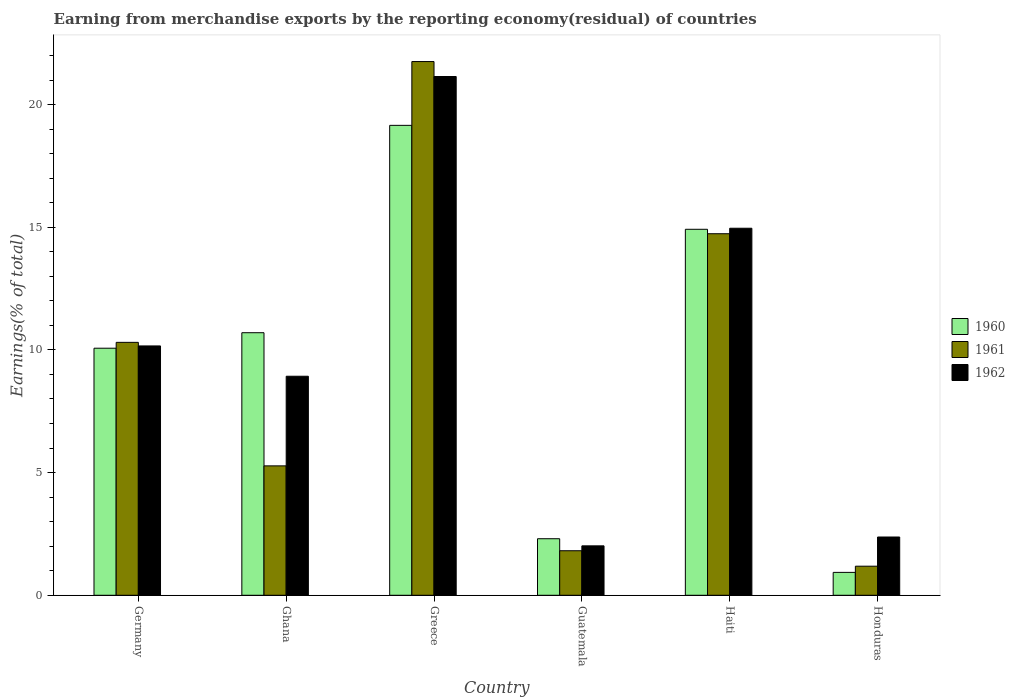How many different coloured bars are there?
Your answer should be compact. 3. Are the number of bars per tick equal to the number of legend labels?
Make the answer very short. Yes. Are the number of bars on each tick of the X-axis equal?
Offer a terse response. Yes. How many bars are there on the 4th tick from the left?
Give a very brief answer. 3. What is the label of the 6th group of bars from the left?
Give a very brief answer. Honduras. In how many cases, is the number of bars for a given country not equal to the number of legend labels?
Your answer should be compact. 0. What is the percentage of amount earned from merchandise exports in 1961 in Guatemala?
Your answer should be very brief. 1.81. Across all countries, what is the maximum percentage of amount earned from merchandise exports in 1960?
Give a very brief answer. 19.15. Across all countries, what is the minimum percentage of amount earned from merchandise exports in 1960?
Offer a very short reply. 0.93. In which country was the percentage of amount earned from merchandise exports in 1960 minimum?
Keep it short and to the point. Honduras. What is the total percentage of amount earned from merchandise exports in 1962 in the graph?
Your response must be concise. 59.58. What is the difference between the percentage of amount earned from merchandise exports in 1961 in Ghana and that in Guatemala?
Your answer should be very brief. 3.46. What is the difference between the percentage of amount earned from merchandise exports in 1960 in Ghana and the percentage of amount earned from merchandise exports in 1962 in Haiti?
Give a very brief answer. -4.26. What is the average percentage of amount earned from merchandise exports in 1960 per country?
Ensure brevity in your answer.  9.68. What is the difference between the percentage of amount earned from merchandise exports of/in 1961 and percentage of amount earned from merchandise exports of/in 1960 in Germany?
Your response must be concise. 0.24. What is the ratio of the percentage of amount earned from merchandise exports in 1960 in Germany to that in Greece?
Ensure brevity in your answer.  0.53. Is the difference between the percentage of amount earned from merchandise exports in 1961 in Ghana and Greece greater than the difference between the percentage of amount earned from merchandise exports in 1960 in Ghana and Greece?
Your answer should be compact. No. What is the difference between the highest and the second highest percentage of amount earned from merchandise exports in 1962?
Offer a very short reply. -10.98. What is the difference between the highest and the lowest percentage of amount earned from merchandise exports in 1960?
Offer a very short reply. 18.22. In how many countries, is the percentage of amount earned from merchandise exports in 1962 greater than the average percentage of amount earned from merchandise exports in 1962 taken over all countries?
Offer a terse response. 3. What does the 2nd bar from the left in Greece represents?
Keep it short and to the point. 1961. What does the 2nd bar from the right in Guatemala represents?
Provide a short and direct response. 1961. Is it the case that in every country, the sum of the percentage of amount earned from merchandise exports in 1962 and percentage of amount earned from merchandise exports in 1960 is greater than the percentage of amount earned from merchandise exports in 1961?
Offer a very short reply. Yes. How many bars are there?
Your answer should be compact. 18. Are all the bars in the graph horizontal?
Make the answer very short. No. Does the graph contain grids?
Provide a succinct answer. No. Where does the legend appear in the graph?
Your answer should be compact. Center right. How many legend labels are there?
Ensure brevity in your answer.  3. How are the legend labels stacked?
Your answer should be very brief. Vertical. What is the title of the graph?
Provide a short and direct response. Earning from merchandise exports by the reporting economy(residual) of countries. What is the label or title of the X-axis?
Your answer should be compact. Country. What is the label or title of the Y-axis?
Make the answer very short. Earnings(% of total). What is the Earnings(% of total) of 1960 in Germany?
Ensure brevity in your answer.  10.07. What is the Earnings(% of total) of 1961 in Germany?
Your response must be concise. 10.31. What is the Earnings(% of total) of 1962 in Germany?
Your answer should be very brief. 10.16. What is the Earnings(% of total) in 1960 in Ghana?
Your answer should be very brief. 10.7. What is the Earnings(% of total) of 1961 in Ghana?
Your response must be concise. 5.27. What is the Earnings(% of total) in 1962 in Ghana?
Offer a very short reply. 8.93. What is the Earnings(% of total) of 1960 in Greece?
Provide a short and direct response. 19.15. What is the Earnings(% of total) in 1961 in Greece?
Keep it short and to the point. 21.75. What is the Earnings(% of total) in 1962 in Greece?
Offer a very short reply. 21.14. What is the Earnings(% of total) in 1960 in Guatemala?
Your response must be concise. 2.3. What is the Earnings(% of total) of 1961 in Guatemala?
Your response must be concise. 1.81. What is the Earnings(% of total) in 1962 in Guatemala?
Keep it short and to the point. 2.01. What is the Earnings(% of total) of 1960 in Haiti?
Give a very brief answer. 14.92. What is the Earnings(% of total) in 1961 in Haiti?
Provide a succinct answer. 14.74. What is the Earnings(% of total) in 1962 in Haiti?
Provide a short and direct response. 14.96. What is the Earnings(% of total) in 1960 in Honduras?
Keep it short and to the point. 0.93. What is the Earnings(% of total) of 1961 in Honduras?
Provide a short and direct response. 1.19. What is the Earnings(% of total) of 1962 in Honduras?
Offer a terse response. 2.38. Across all countries, what is the maximum Earnings(% of total) in 1960?
Make the answer very short. 19.15. Across all countries, what is the maximum Earnings(% of total) in 1961?
Your answer should be compact. 21.75. Across all countries, what is the maximum Earnings(% of total) in 1962?
Give a very brief answer. 21.14. Across all countries, what is the minimum Earnings(% of total) in 1960?
Offer a very short reply. 0.93. Across all countries, what is the minimum Earnings(% of total) in 1961?
Your answer should be compact. 1.19. Across all countries, what is the minimum Earnings(% of total) in 1962?
Provide a succinct answer. 2.01. What is the total Earnings(% of total) in 1960 in the graph?
Ensure brevity in your answer.  58.08. What is the total Earnings(% of total) of 1961 in the graph?
Your answer should be compact. 55.07. What is the total Earnings(% of total) of 1962 in the graph?
Offer a terse response. 59.58. What is the difference between the Earnings(% of total) of 1960 in Germany and that in Ghana?
Offer a very short reply. -0.63. What is the difference between the Earnings(% of total) in 1961 in Germany and that in Ghana?
Provide a succinct answer. 5.03. What is the difference between the Earnings(% of total) of 1962 in Germany and that in Ghana?
Offer a terse response. 1.24. What is the difference between the Earnings(% of total) in 1960 in Germany and that in Greece?
Your answer should be very brief. -9.08. What is the difference between the Earnings(% of total) of 1961 in Germany and that in Greece?
Provide a short and direct response. -11.44. What is the difference between the Earnings(% of total) in 1962 in Germany and that in Greece?
Your answer should be compact. -10.98. What is the difference between the Earnings(% of total) in 1960 in Germany and that in Guatemala?
Provide a short and direct response. 7.76. What is the difference between the Earnings(% of total) of 1961 in Germany and that in Guatemala?
Offer a very short reply. 8.49. What is the difference between the Earnings(% of total) of 1962 in Germany and that in Guatemala?
Keep it short and to the point. 8.15. What is the difference between the Earnings(% of total) in 1960 in Germany and that in Haiti?
Give a very brief answer. -4.85. What is the difference between the Earnings(% of total) of 1961 in Germany and that in Haiti?
Provide a short and direct response. -4.43. What is the difference between the Earnings(% of total) of 1962 in Germany and that in Haiti?
Make the answer very short. -4.8. What is the difference between the Earnings(% of total) in 1960 in Germany and that in Honduras?
Your answer should be very brief. 9.14. What is the difference between the Earnings(% of total) in 1961 in Germany and that in Honduras?
Make the answer very short. 9.12. What is the difference between the Earnings(% of total) of 1962 in Germany and that in Honduras?
Provide a succinct answer. 7.79. What is the difference between the Earnings(% of total) of 1960 in Ghana and that in Greece?
Your answer should be compact. -8.45. What is the difference between the Earnings(% of total) of 1961 in Ghana and that in Greece?
Offer a very short reply. -16.48. What is the difference between the Earnings(% of total) of 1962 in Ghana and that in Greece?
Offer a very short reply. -12.22. What is the difference between the Earnings(% of total) of 1960 in Ghana and that in Guatemala?
Ensure brevity in your answer.  8.4. What is the difference between the Earnings(% of total) of 1961 in Ghana and that in Guatemala?
Keep it short and to the point. 3.46. What is the difference between the Earnings(% of total) of 1962 in Ghana and that in Guatemala?
Provide a succinct answer. 6.91. What is the difference between the Earnings(% of total) of 1960 in Ghana and that in Haiti?
Give a very brief answer. -4.22. What is the difference between the Earnings(% of total) in 1961 in Ghana and that in Haiti?
Provide a succinct answer. -9.46. What is the difference between the Earnings(% of total) in 1962 in Ghana and that in Haiti?
Your response must be concise. -6.03. What is the difference between the Earnings(% of total) in 1960 in Ghana and that in Honduras?
Keep it short and to the point. 9.77. What is the difference between the Earnings(% of total) of 1961 in Ghana and that in Honduras?
Your response must be concise. 4.09. What is the difference between the Earnings(% of total) in 1962 in Ghana and that in Honduras?
Keep it short and to the point. 6.55. What is the difference between the Earnings(% of total) of 1960 in Greece and that in Guatemala?
Ensure brevity in your answer.  16.85. What is the difference between the Earnings(% of total) of 1961 in Greece and that in Guatemala?
Keep it short and to the point. 19.94. What is the difference between the Earnings(% of total) in 1962 in Greece and that in Guatemala?
Ensure brevity in your answer.  19.13. What is the difference between the Earnings(% of total) in 1960 in Greece and that in Haiti?
Offer a terse response. 4.24. What is the difference between the Earnings(% of total) in 1961 in Greece and that in Haiti?
Give a very brief answer. 7.02. What is the difference between the Earnings(% of total) in 1962 in Greece and that in Haiti?
Make the answer very short. 6.18. What is the difference between the Earnings(% of total) in 1960 in Greece and that in Honduras?
Provide a succinct answer. 18.22. What is the difference between the Earnings(% of total) of 1961 in Greece and that in Honduras?
Provide a succinct answer. 20.57. What is the difference between the Earnings(% of total) of 1962 in Greece and that in Honduras?
Provide a succinct answer. 18.77. What is the difference between the Earnings(% of total) of 1960 in Guatemala and that in Haiti?
Provide a succinct answer. -12.61. What is the difference between the Earnings(% of total) in 1961 in Guatemala and that in Haiti?
Offer a very short reply. -12.92. What is the difference between the Earnings(% of total) of 1962 in Guatemala and that in Haiti?
Keep it short and to the point. -12.94. What is the difference between the Earnings(% of total) of 1960 in Guatemala and that in Honduras?
Provide a short and direct response. 1.37. What is the difference between the Earnings(% of total) in 1961 in Guatemala and that in Honduras?
Keep it short and to the point. 0.63. What is the difference between the Earnings(% of total) of 1962 in Guatemala and that in Honduras?
Provide a short and direct response. -0.36. What is the difference between the Earnings(% of total) of 1960 in Haiti and that in Honduras?
Ensure brevity in your answer.  13.98. What is the difference between the Earnings(% of total) in 1961 in Haiti and that in Honduras?
Provide a short and direct response. 13.55. What is the difference between the Earnings(% of total) in 1962 in Haiti and that in Honduras?
Your answer should be very brief. 12.58. What is the difference between the Earnings(% of total) of 1960 in Germany and the Earnings(% of total) of 1961 in Ghana?
Offer a terse response. 4.79. What is the difference between the Earnings(% of total) of 1960 in Germany and the Earnings(% of total) of 1962 in Ghana?
Provide a succinct answer. 1.14. What is the difference between the Earnings(% of total) in 1961 in Germany and the Earnings(% of total) in 1962 in Ghana?
Give a very brief answer. 1.38. What is the difference between the Earnings(% of total) in 1960 in Germany and the Earnings(% of total) in 1961 in Greece?
Ensure brevity in your answer.  -11.68. What is the difference between the Earnings(% of total) of 1960 in Germany and the Earnings(% of total) of 1962 in Greece?
Give a very brief answer. -11.07. What is the difference between the Earnings(% of total) of 1961 in Germany and the Earnings(% of total) of 1962 in Greece?
Keep it short and to the point. -10.84. What is the difference between the Earnings(% of total) of 1960 in Germany and the Earnings(% of total) of 1961 in Guatemala?
Your answer should be very brief. 8.25. What is the difference between the Earnings(% of total) of 1960 in Germany and the Earnings(% of total) of 1962 in Guatemala?
Make the answer very short. 8.05. What is the difference between the Earnings(% of total) of 1961 in Germany and the Earnings(% of total) of 1962 in Guatemala?
Provide a succinct answer. 8.29. What is the difference between the Earnings(% of total) of 1960 in Germany and the Earnings(% of total) of 1961 in Haiti?
Make the answer very short. -4.67. What is the difference between the Earnings(% of total) of 1960 in Germany and the Earnings(% of total) of 1962 in Haiti?
Keep it short and to the point. -4.89. What is the difference between the Earnings(% of total) of 1961 in Germany and the Earnings(% of total) of 1962 in Haiti?
Your answer should be very brief. -4.65. What is the difference between the Earnings(% of total) in 1960 in Germany and the Earnings(% of total) in 1961 in Honduras?
Give a very brief answer. 8.88. What is the difference between the Earnings(% of total) in 1960 in Germany and the Earnings(% of total) in 1962 in Honduras?
Offer a very short reply. 7.69. What is the difference between the Earnings(% of total) in 1961 in Germany and the Earnings(% of total) in 1962 in Honduras?
Keep it short and to the point. 7.93. What is the difference between the Earnings(% of total) of 1960 in Ghana and the Earnings(% of total) of 1961 in Greece?
Offer a very short reply. -11.05. What is the difference between the Earnings(% of total) of 1960 in Ghana and the Earnings(% of total) of 1962 in Greece?
Ensure brevity in your answer.  -10.44. What is the difference between the Earnings(% of total) in 1961 in Ghana and the Earnings(% of total) in 1962 in Greece?
Offer a terse response. -15.87. What is the difference between the Earnings(% of total) in 1960 in Ghana and the Earnings(% of total) in 1961 in Guatemala?
Your response must be concise. 8.89. What is the difference between the Earnings(% of total) of 1960 in Ghana and the Earnings(% of total) of 1962 in Guatemala?
Give a very brief answer. 8.69. What is the difference between the Earnings(% of total) in 1961 in Ghana and the Earnings(% of total) in 1962 in Guatemala?
Offer a very short reply. 3.26. What is the difference between the Earnings(% of total) of 1960 in Ghana and the Earnings(% of total) of 1961 in Haiti?
Provide a succinct answer. -4.03. What is the difference between the Earnings(% of total) of 1960 in Ghana and the Earnings(% of total) of 1962 in Haiti?
Provide a short and direct response. -4.26. What is the difference between the Earnings(% of total) in 1961 in Ghana and the Earnings(% of total) in 1962 in Haiti?
Provide a succinct answer. -9.68. What is the difference between the Earnings(% of total) in 1960 in Ghana and the Earnings(% of total) in 1961 in Honduras?
Keep it short and to the point. 9.52. What is the difference between the Earnings(% of total) of 1960 in Ghana and the Earnings(% of total) of 1962 in Honduras?
Give a very brief answer. 8.33. What is the difference between the Earnings(% of total) in 1961 in Ghana and the Earnings(% of total) in 1962 in Honduras?
Your response must be concise. 2.9. What is the difference between the Earnings(% of total) in 1960 in Greece and the Earnings(% of total) in 1961 in Guatemala?
Offer a terse response. 17.34. What is the difference between the Earnings(% of total) in 1960 in Greece and the Earnings(% of total) in 1962 in Guatemala?
Make the answer very short. 17.14. What is the difference between the Earnings(% of total) in 1961 in Greece and the Earnings(% of total) in 1962 in Guatemala?
Provide a short and direct response. 19.74. What is the difference between the Earnings(% of total) in 1960 in Greece and the Earnings(% of total) in 1961 in Haiti?
Offer a very short reply. 4.42. What is the difference between the Earnings(% of total) in 1960 in Greece and the Earnings(% of total) in 1962 in Haiti?
Offer a very short reply. 4.19. What is the difference between the Earnings(% of total) in 1961 in Greece and the Earnings(% of total) in 1962 in Haiti?
Your answer should be compact. 6.79. What is the difference between the Earnings(% of total) in 1960 in Greece and the Earnings(% of total) in 1961 in Honduras?
Make the answer very short. 17.97. What is the difference between the Earnings(% of total) in 1960 in Greece and the Earnings(% of total) in 1962 in Honduras?
Provide a short and direct response. 16.78. What is the difference between the Earnings(% of total) of 1961 in Greece and the Earnings(% of total) of 1962 in Honduras?
Your response must be concise. 19.38. What is the difference between the Earnings(% of total) in 1960 in Guatemala and the Earnings(% of total) in 1961 in Haiti?
Offer a terse response. -12.43. What is the difference between the Earnings(% of total) in 1960 in Guatemala and the Earnings(% of total) in 1962 in Haiti?
Offer a terse response. -12.65. What is the difference between the Earnings(% of total) of 1961 in Guatemala and the Earnings(% of total) of 1962 in Haiti?
Give a very brief answer. -13.14. What is the difference between the Earnings(% of total) in 1960 in Guatemala and the Earnings(% of total) in 1961 in Honduras?
Give a very brief answer. 1.12. What is the difference between the Earnings(% of total) of 1960 in Guatemala and the Earnings(% of total) of 1962 in Honduras?
Your answer should be compact. -0.07. What is the difference between the Earnings(% of total) in 1961 in Guatemala and the Earnings(% of total) in 1962 in Honduras?
Ensure brevity in your answer.  -0.56. What is the difference between the Earnings(% of total) of 1960 in Haiti and the Earnings(% of total) of 1961 in Honduras?
Provide a short and direct response. 13.73. What is the difference between the Earnings(% of total) of 1960 in Haiti and the Earnings(% of total) of 1962 in Honduras?
Ensure brevity in your answer.  12.54. What is the difference between the Earnings(% of total) in 1961 in Haiti and the Earnings(% of total) in 1962 in Honduras?
Offer a terse response. 12.36. What is the average Earnings(% of total) of 1960 per country?
Provide a succinct answer. 9.68. What is the average Earnings(% of total) in 1961 per country?
Ensure brevity in your answer.  9.18. What is the average Earnings(% of total) of 1962 per country?
Provide a succinct answer. 9.93. What is the difference between the Earnings(% of total) of 1960 and Earnings(% of total) of 1961 in Germany?
Your response must be concise. -0.24. What is the difference between the Earnings(% of total) in 1960 and Earnings(% of total) in 1962 in Germany?
Your answer should be very brief. -0.09. What is the difference between the Earnings(% of total) of 1961 and Earnings(% of total) of 1962 in Germany?
Offer a terse response. 0.15. What is the difference between the Earnings(% of total) of 1960 and Earnings(% of total) of 1961 in Ghana?
Provide a succinct answer. 5.43. What is the difference between the Earnings(% of total) of 1960 and Earnings(% of total) of 1962 in Ghana?
Your response must be concise. 1.77. What is the difference between the Earnings(% of total) in 1961 and Earnings(% of total) in 1962 in Ghana?
Ensure brevity in your answer.  -3.65. What is the difference between the Earnings(% of total) in 1960 and Earnings(% of total) in 1961 in Greece?
Provide a succinct answer. -2.6. What is the difference between the Earnings(% of total) of 1960 and Earnings(% of total) of 1962 in Greece?
Make the answer very short. -1.99. What is the difference between the Earnings(% of total) of 1961 and Earnings(% of total) of 1962 in Greece?
Your response must be concise. 0.61. What is the difference between the Earnings(% of total) of 1960 and Earnings(% of total) of 1961 in Guatemala?
Offer a very short reply. 0.49. What is the difference between the Earnings(% of total) in 1960 and Earnings(% of total) in 1962 in Guatemala?
Provide a succinct answer. 0.29. What is the difference between the Earnings(% of total) in 1961 and Earnings(% of total) in 1962 in Guatemala?
Make the answer very short. -0.2. What is the difference between the Earnings(% of total) of 1960 and Earnings(% of total) of 1961 in Haiti?
Keep it short and to the point. 0.18. What is the difference between the Earnings(% of total) in 1960 and Earnings(% of total) in 1962 in Haiti?
Offer a very short reply. -0.04. What is the difference between the Earnings(% of total) in 1961 and Earnings(% of total) in 1962 in Haiti?
Your response must be concise. -0.22. What is the difference between the Earnings(% of total) of 1960 and Earnings(% of total) of 1961 in Honduras?
Offer a terse response. -0.25. What is the difference between the Earnings(% of total) of 1960 and Earnings(% of total) of 1962 in Honduras?
Your answer should be very brief. -1.44. What is the difference between the Earnings(% of total) in 1961 and Earnings(% of total) in 1962 in Honduras?
Offer a very short reply. -1.19. What is the ratio of the Earnings(% of total) in 1960 in Germany to that in Ghana?
Provide a short and direct response. 0.94. What is the ratio of the Earnings(% of total) of 1961 in Germany to that in Ghana?
Your answer should be compact. 1.95. What is the ratio of the Earnings(% of total) of 1962 in Germany to that in Ghana?
Provide a short and direct response. 1.14. What is the ratio of the Earnings(% of total) of 1960 in Germany to that in Greece?
Keep it short and to the point. 0.53. What is the ratio of the Earnings(% of total) in 1961 in Germany to that in Greece?
Make the answer very short. 0.47. What is the ratio of the Earnings(% of total) of 1962 in Germany to that in Greece?
Your response must be concise. 0.48. What is the ratio of the Earnings(% of total) of 1960 in Germany to that in Guatemala?
Make the answer very short. 4.37. What is the ratio of the Earnings(% of total) of 1961 in Germany to that in Guatemala?
Offer a very short reply. 5.68. What is the ratio of the Earnings(% of total) in 1962 in Germany to that in Guatemala?
Make the answer very short. 5.04. What is the ratio of the Earnings(% of total) of 1960 in Germany to that in Haiti?
Provide a short and direct response. 0.68. What is the ratio of the Earnings(% of total) of 1961 in Germany to that in Haiti?
Your answer should be very brief. 0.7. What is the ratio of the Earnings(% of total) in 1962 in Germany to that in Haiti?
Provide a short and direct response. 0.68. What is the ratio of the Earnings(% of total) in 1960 in Germany to that in Honduras?
Give a very brief answer. 10.79. What is the ratio of the Earnings(% of total) in 1961 in Germany to that in Honduras?
Make the answer very short. 8.7. What is the ratio of the Earnings(% of total) in 1962 in Germany to that in Honduras?
Offer a terse response. 4.28. What is the ratio of the Earnings(% of total) in 1960 in Ghana to that in Greece?
Offer a very short reply. 0.56. What is the ratio of the Earnings(% of total) in 1961 in Ghana to that in Greece?
Make the answer very short. 0.24. What is the ratio of the Earnings(% of total) of 1962 in Ghana to that in Greece?
Provide a short and direct response. 0.42. What is the ratio of the Earnings(% of total) in 1960 in Ghana to that in Guatemala?
Offer a very short reply. 4.64. What is the ratio of the Earnings(% of total) of 1961 in Ghana to that in Guatemala?
Your response must be concise. 2.91. What is the ratio of the Earnings(% of total) in 1962 in Ghana to that in Guatemala?
Offer a terse response. 4.43. What is the ratio of the Earnings(% of total) of 1960 in Ghana to that in Haiti?
Your answer should be compact. 0.72. What is the ratio of the Earnings(% of total) of 1961 in Ghana to that in Haiti?
Give a very brief answer. 0.36. What is the ratio of the Earnings(% of total) in 1962 in Ghana to that in Haiti?
Ensure brevity in your answer.  0.6. What is the ratio of the Earnings(% of total) of 1960 in Ghana to that in Honduras?
Your response must be concise. 11.47. What is the ratio of the Earnings(% of total) in 1961 in Ghana to that in Honduras?
Offer a terse response. 4.45. What is the ratio of the Earnings(% of total) in 1962 in Ghana to that in Honduras?
Offer a terse response. 3.76. What is the ratio of the Earnings(% of total) of 1960 in Greece to that in Guatemala?
Provide a succinct answer. 8.31. What is the ratio of the Earnings(% of total) of 1961 in Greece to that in Guatemala?
Your response must be concise. 11.99. What is the ratio of the Earnings(% of total) of 1962 in Greece to that in Guatemala?
Offer a very short reply. 10.49. What is the ratio of the Earnings(% of total) in 1960 in Greece to that in Haiti?
Ensure brevity in your answer.  1.28. What is the ratio of the Earnings(% of total) in 1961 in Greece to that in Haiti?
Your answer should be very brief. 1.48. What is the ratio of the Earnings(% of total) in 1962 in Greece to that in Haiti?
Give a very brief answer. 1.41. What is the ratio of the Earnings(% of total) of 1960 in Greece to that in Honduras?
Your answer should be compact. 20.53. What is the ratio of the Earnings(% of total) in 1961 in Greece to that in Honduras?
Offer a very short reply. 18.35. What is the ratio of the Earnings(% of total) in 1962 in Greece to that in Honduras?
Ensure brevity in your answer.  8.9. What is the ratio of the Earnings(% of total) in 1960 in Guatemala to that in Haiti?
Give a very brief answer. 0.15. What is the ratio of the Earnings(% of total) in 1961 in Guatemala to that in Haiti?
Make the answer very short. 0.12. What is the ratio of the Earnings(% of total) of 1962 in Guatemala to that in Haiti?
Keep it short and to the point. 0.13. What is the ratio of the Earnings(% of total) of 1960 in Guatemala to that in Honduras?
Give a very brief answer. 2.47. What is the ratio of the Earnings(% of total) of 1961 in Guatemala to that in Honduras?
Offer a terse response. 1.53. What is the ratio of the Earnings(% of total) in 1962 in Guatemala to that in Honduras?
Offer a terse response. 0.85. What is the ratio of the Earnings(% of total) of 1960 in Haiti to that in Honduras?
Your answer should be compact. 15.99. What is the ratio of the Earnings(% of total) of 1961 in Haiti to that in Honduras?
Ensure brevity in your answer.  12.43. What is the ratio of the Earnings(% of total) in 1962 in Haiti to that in Honduras?
Offer a terse response. 6.3. What is the difference between the highest and the second highest Earnings(% of total) of 1960?
Provide a short and direct response. 4.24. What is the difference between the highest and the second highest Earnings(% of total) in 1961?
Offer a very short reply. 7.02. What is the difference between the highest and the second highest Earnings(% of total) in 1962?
Offer a very short reply. 6.18. What is the difference between the highest and the lowest Earnings(% of total) of 1960?
Your answer should be very brief. 18.22. What is the difference between the highest and the lowest Earnings(% of total) of 1961?
Make the answer very short. 20.57. What is the difference between the highest and the lowest Earnings(% of total) in 1962?
Your answer should be very brief. 19.13. 